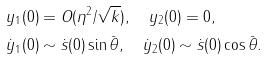Convert formula to latex. <formula><loc_0><loc_0><loc_500><loc_500>& y _ { 1 } ( 0 ) = O ( \eta ^ { 2 } / \sqrt { k } ) , \quad y _ { 2 } ( 0 ) = 0 , \\ & \dot { y } _ { 1 } ( 0 ) \sim \dot { s } ( 0 ) \sin \bar { \theta } , \quad \dot { y } _ { 2 } ( 0 ) \sim \dot { s } ( 0 ) \cos \bar { \theta } .</formula> 